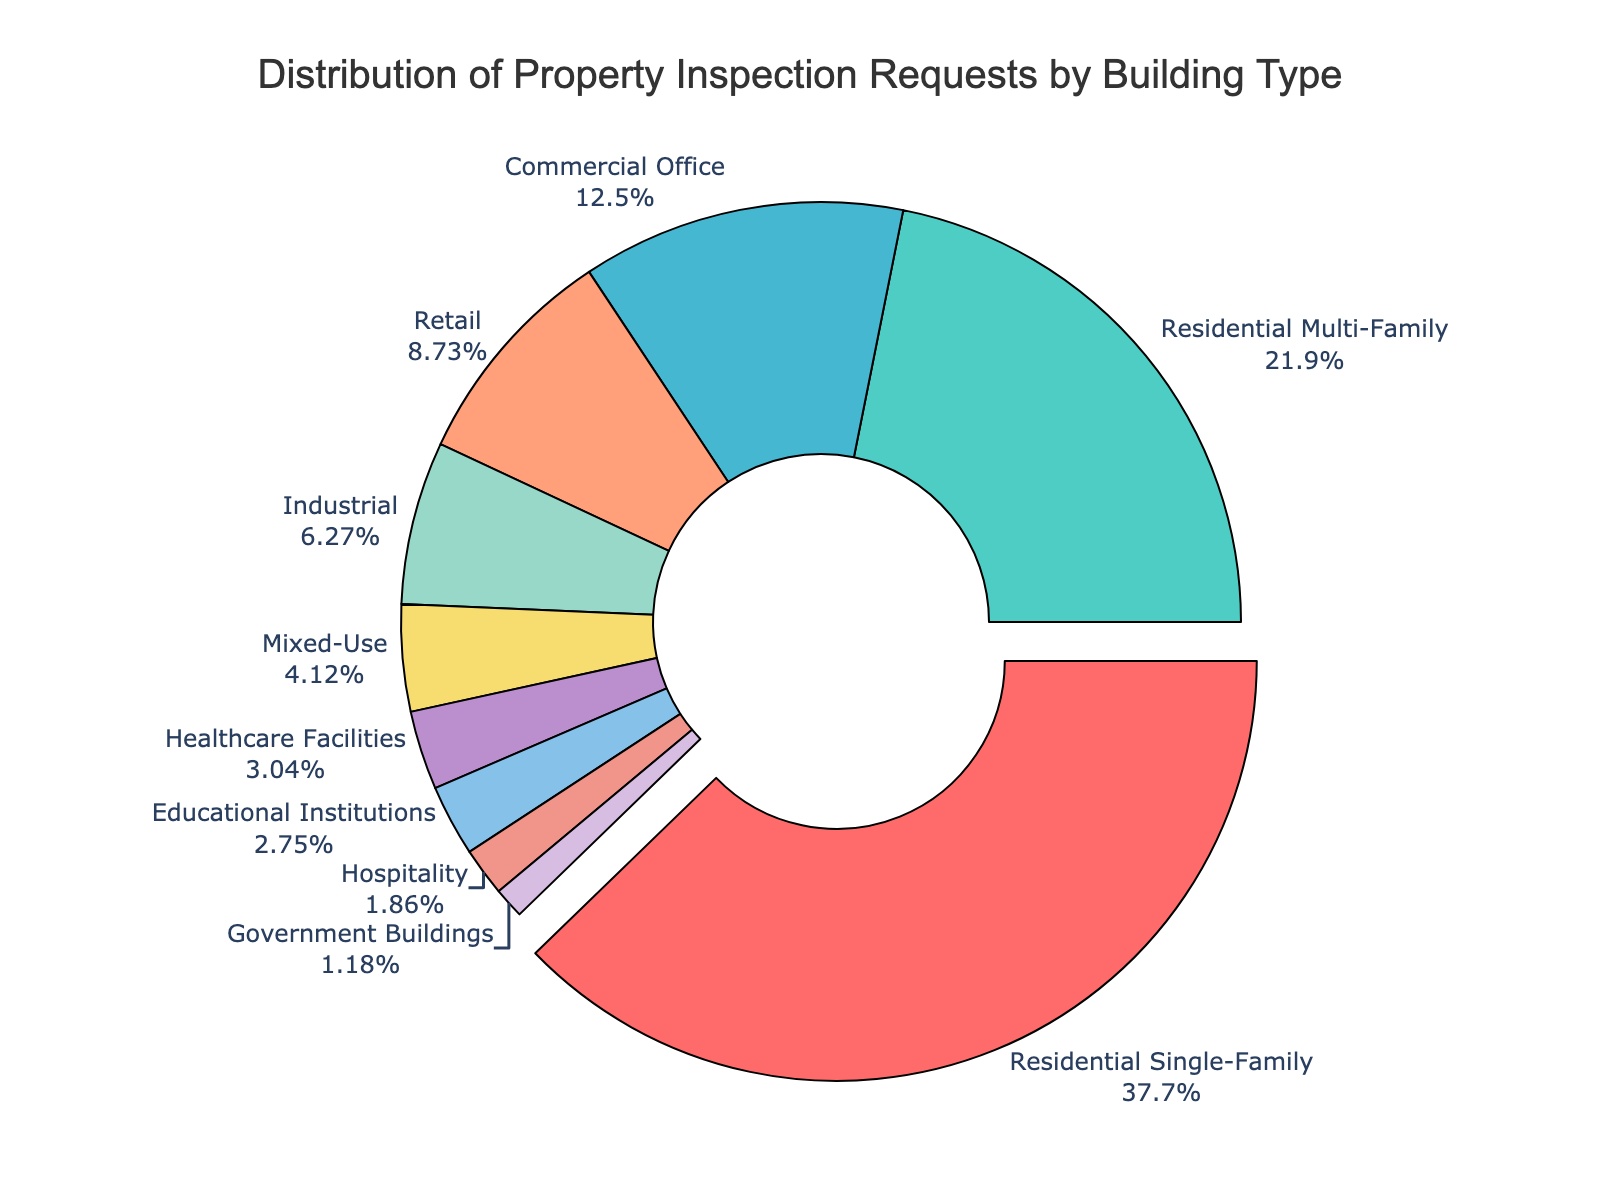Which building type has the highest percentage of inspection requests? The pie chart shows that 'Residential Single-Family' has the largest pulled-out segment, indicating the highest percentage.
Answer: Residential Single-Family What percentage of inspection requests are for Residential Multi-Family and Commercial Office combined? The percentages for Residential Multi-Family and Commercial Office are 22.3% and 12.7%, respectively. Adding them gives 22.3 + 12.7 = 35%.
Answer: 35% How does the percentage of requests for Retail compare to that for Industrial buildings? The percentage of requests for Retail is 8.9%, while for Industrial buildings, it is 6.4%. 8.9% is greater than 6.4%.
Answer: Retail has a higher percentage Which building type has the smallest percentage of inspection requests? The pie chart shows that 'Government Buildings' has the smallest segment, indicating the lowest percentage of inspection requests.
Answer: Government Buildings What is the difference in percentage points between Residential Single-Family and Healthcare Facilities requests? The percentage for Residential Single-Family is 38.5%, and for Healthcare Facilities, it is 3.1%. The difference is 38.5 - 3.1 = 35.4 percentage points.
Answer: 35.4 percentage points Combine the percentages of Hospitality and Government Buildings to find their total. The percentages for Hospitality and Government Buildings are 1.9% and 1.2%, respectively. Adding them gives 1.9 + 1.2 = 3.1%.
Answer: 3.1% Which building types together make up more than 50% of the inspection requests? Residential Single-Family (38.5%) and Residential Multi-Family (22.3%) together are 38.5 + 22.3 = 60.8%, which is more than 50%.
Answer: Residential Single-Family and Residential Multi-Family Compare the number of properties inspected for Mixed-Use with Educational Institutions. Which gets more? The percentage for Mixed-Use is 4.2%, and for Educational Institutions, it is 2.8%. Mixed-Use has a higher percentage, indicating more inspections.
Answer: Mixed-Use By how much do the inspection requests for Residential Single-Family surpass those for the next highest (Residential Multi-Family)? The percentage for Residential Single-Family is 38.5%, and for Residential Multi-Family, it is 22.3%. The difference is 38.5 - 22.3 = 16.2 percentage points.
Answer: 16.2 percentage points What percentage of requests fall under the 'Non-Residential' categories (excluding all Residential and Mixed-Use)? Non-Residential categories are Commercial Office (12.7%), Retail (8.9%), Industrial (6.4%), Healthcare Facilities (3.1%), Educational Institutions (2.8%), Hospitality (1.9%), and Government Buildings (1.2%). Adding these gives 12.7 + 8.9 + 6.4 + 3.1 + 2.8 + 1.9 + 1.2 = 37%.
Answer: 37% 